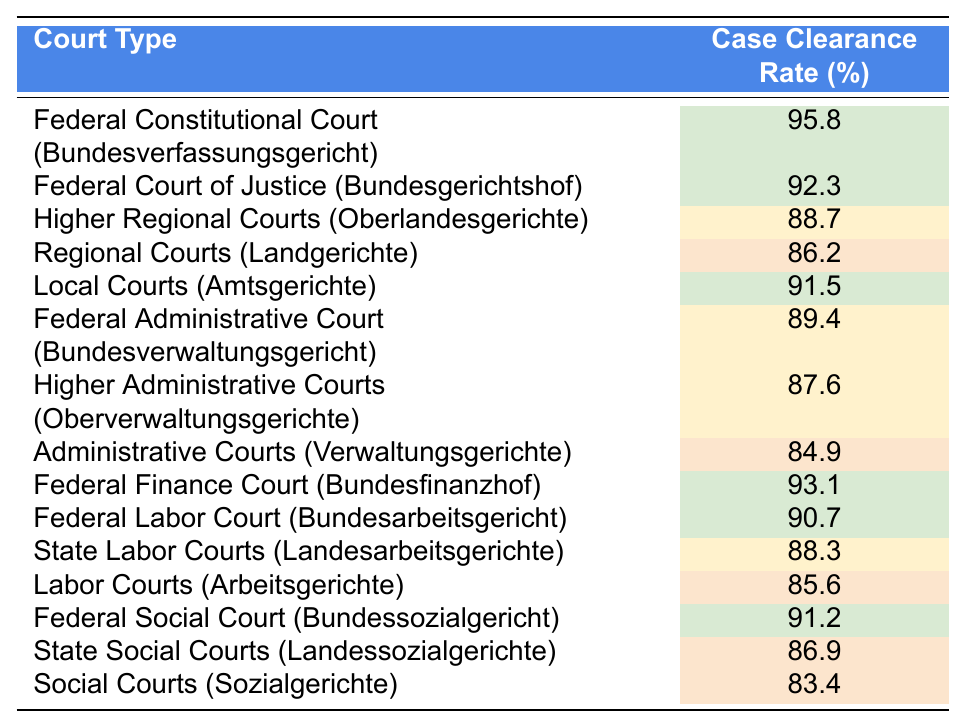What is the case clearance rate of the Federal Constitutional Court? According to the table, the Federal Constitutional Court has a case clearance rate of 95.8%.
Answer: 95.8% Which court type has the lowest case clearance rate? The Social Courts have the lowest case clearance rate at 83.4%.
Answer: 83.4% What is the average case clearance rate for the Federal Courts? The average for the Federal Courts (Federal Constitutional Court, Federal Court of Justice, Federal Administrative Court, Federal Finance Court, Federal Labor Court, and Federal Social Court) is (95.8 + 92.3 + 89.4 + 93.1 + 90.7 + 91.2) / 6 = 90.5%.
Answer: 90.5% True or False: Higher Regional Courts have a higher clearance rate than Regional Courts. The Higher Regional Courts have a clearance rate of 88.7%, while the Regional Courts have a clearance rate of 86.2%, so the statement is true.
Answer: True What is the difference in case clearance rates between Local Courts and Administrative Courts? Local Courts have a case clearance rate of 91.5%, and Administrative Courts have 84.9%. The difference is 91.5 - 84.9 = 6.6%.
Answer: 6.6% How many court types have a clearance rate higher than 90%? The court types with rates higher than 90% are the Federal Constitutional Court, Federal Court of Justice, Federal Finance Court, Federal Labor Court, and Federal Social Court, totaling 5.
Answer: 5 Which court type has a case clearance rate closest to 90%? The court type with the clearance rate closest to 90% is the Federal Labor Court at 90.7%.
Answer: 90.7% What percentage of the courts listed have a clearance rate below 85%? The only courts below 85% are the Administrative Courts at 84.9% and Social Courts at 83.4%; therefore, 2 out of 15 courts, which is 2/15 = 13.3%.
Answer: 13.3% 